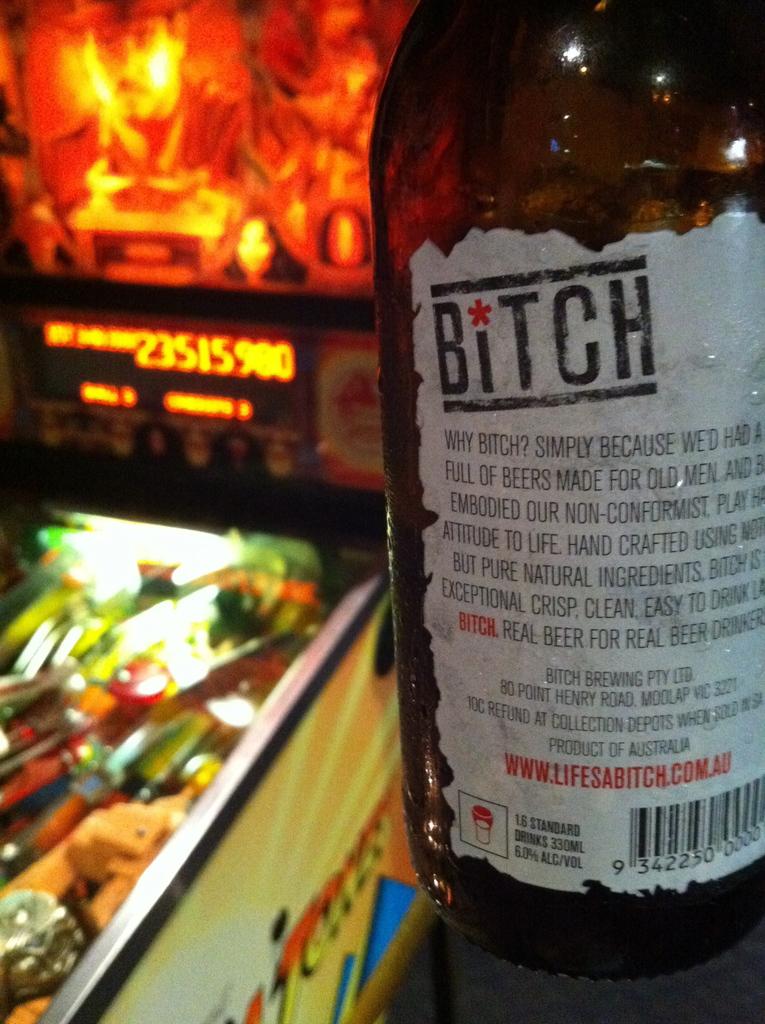What is the website for this beer?
Keep it short and to the point. Www.lifesabitch.com.au. Whats the content in the bottle?
Provide a short and direct response. Beer. 